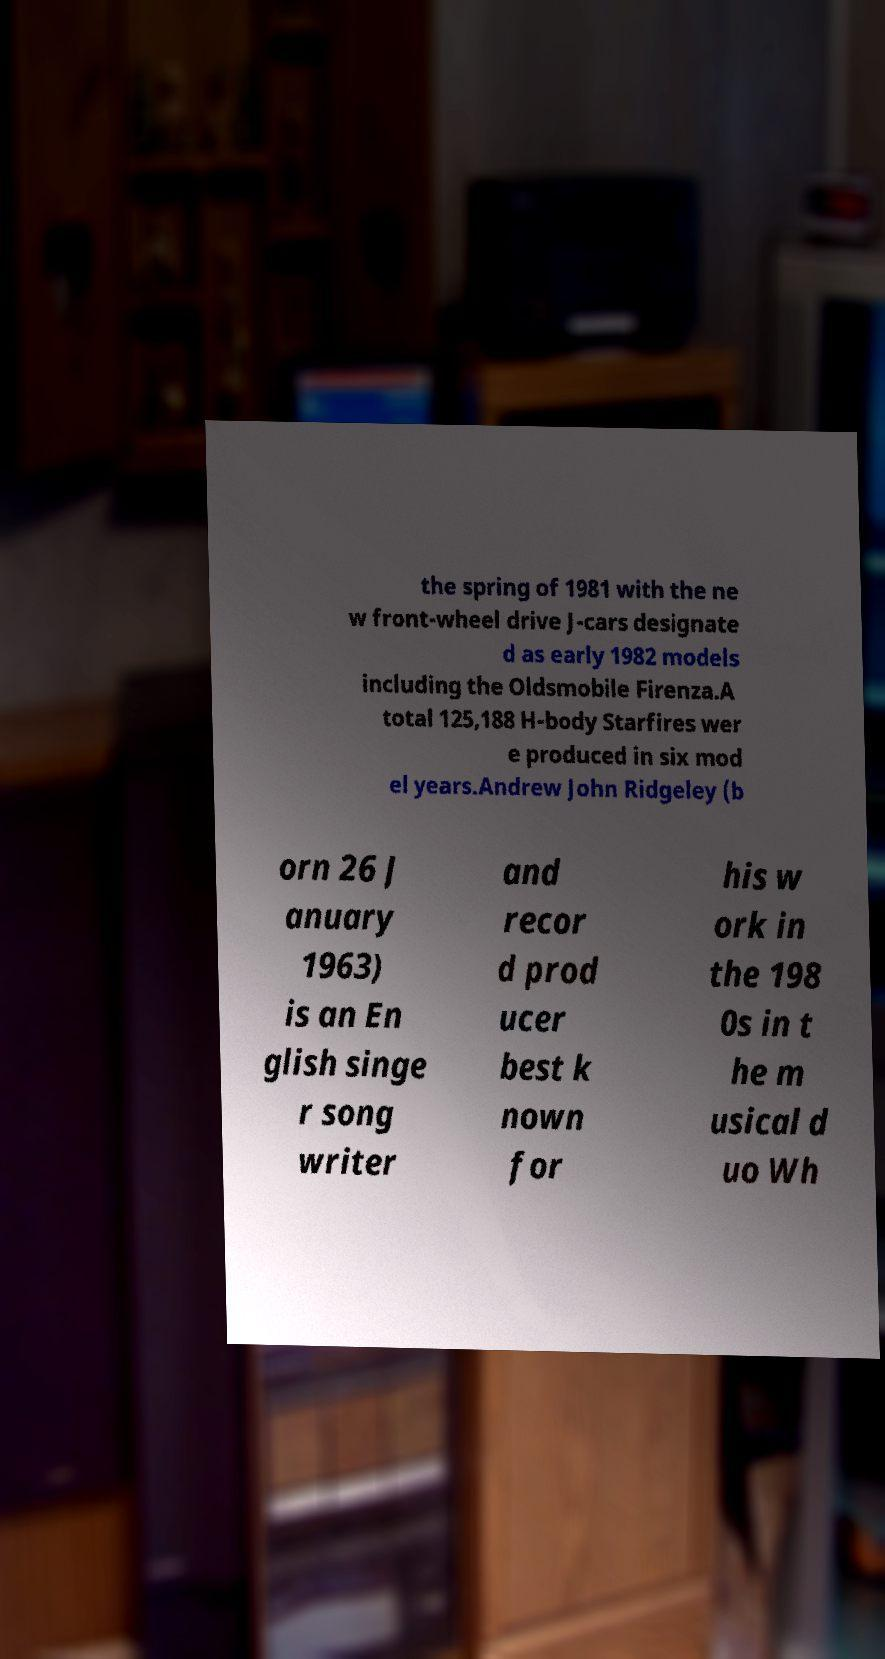For documentation purposes, I need the text within this image transcribed. Could you provide that? the spring of 1981 with the ne w front-wheel drive J-cars designate d as early 1982 models including the Oldsmobile Firenza.A total 125,188 H-body Starfires wer e produced in six mod el years.Andrew John Ridgeley (b orn 26 J anuary 1963) is an En glish singe r song writer and recor d prod ucer best k nown for his w ork in the 198 0s in t he m usical d uo Wh 